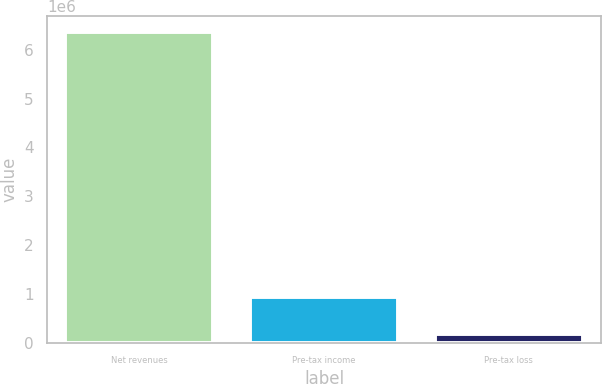Convert chart to OTSL. <chart><loc_0><loc_0><loc_500><loc_500><bar_chart><fcel>Net revenues<fcel>Pre-tax income<fcel>Pre-tax loss<nl><fcel>6.3711e+06<fcel>925346<fcel>169879<nl></chart> 